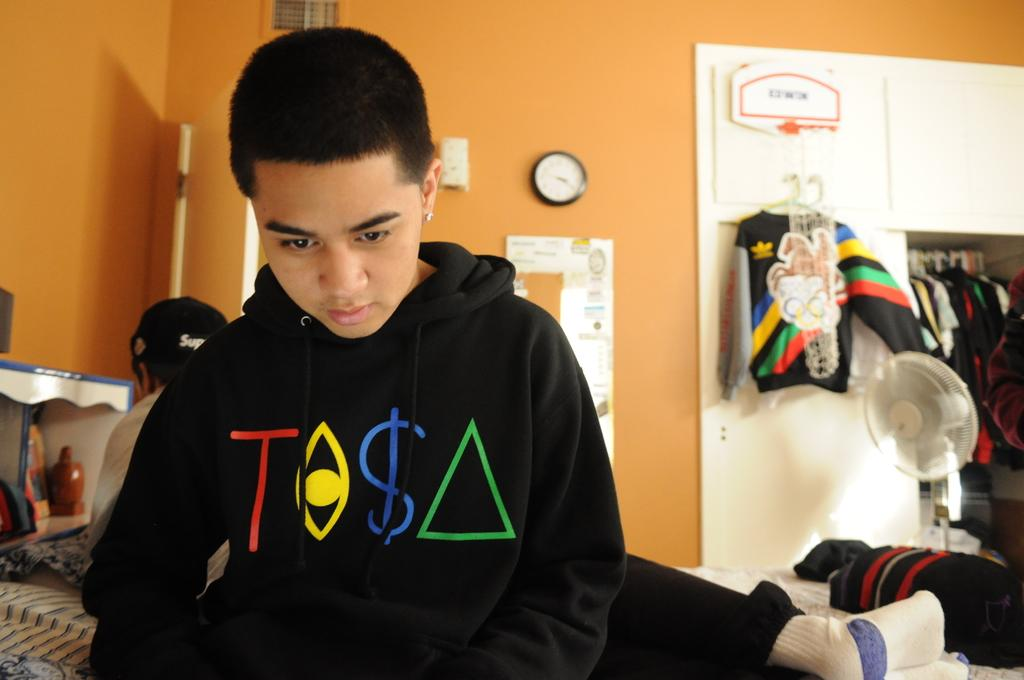<image>
Share a concise interpretation of the image provided. A boy looking down in a room with orange walls and is wearing a black sweatshirt with multi colored letters that says T followed by shapes and the $ sign. 